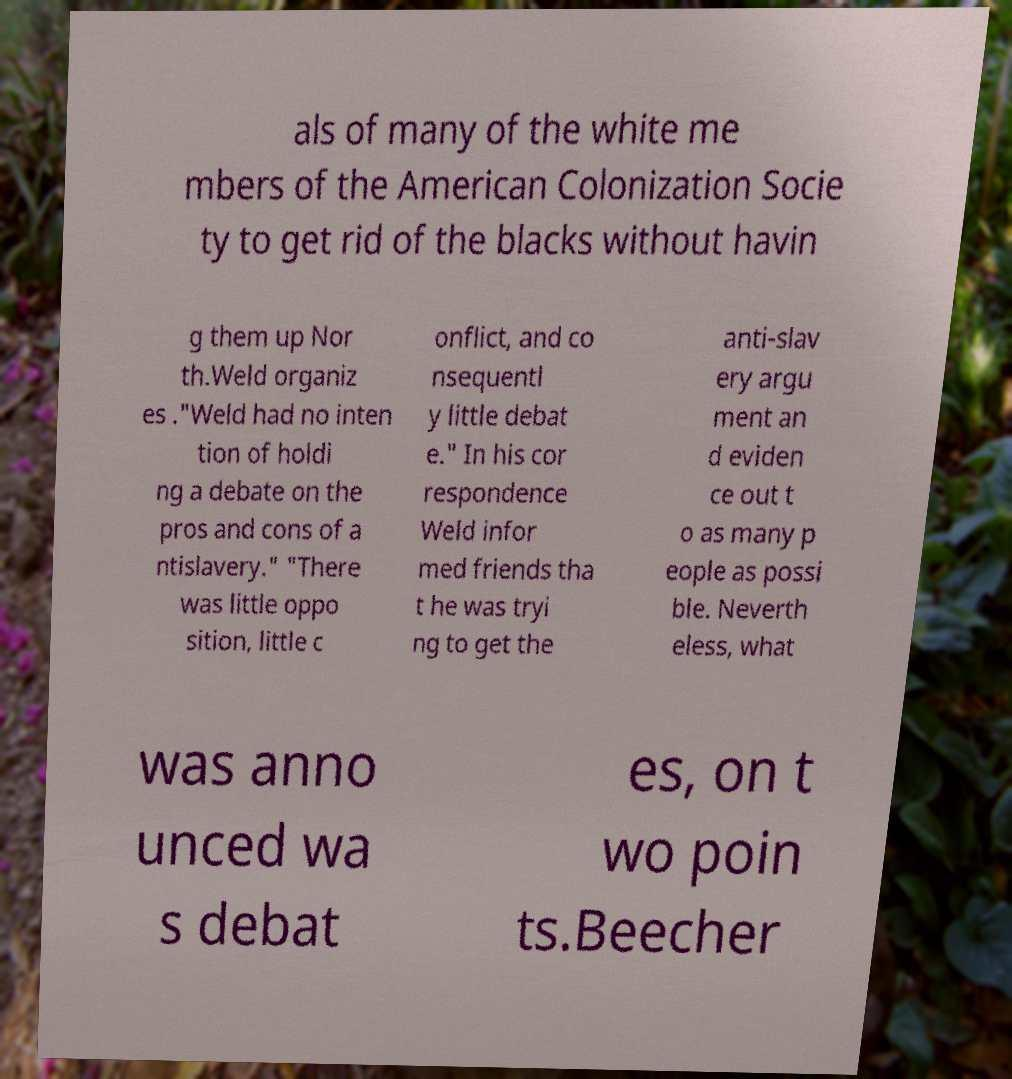Can you read and provide the text displayed in the image?This photo seems to have some interesting text. Can you extract and type it out for me? als of many of the white me mbers of the American Colonization Socie ty to get rid of the blacks without havin g them up Nor th.Weld organiz es ."Weld had no inten tion of holdi ng a debate on the pros and cons of a ntislavery." "There was little oppo sition, little c onflict, and co nsequentl y little debat e." In his cor respondence Weld infor med friends tha t he was tryi ng to get the anti-slav ery argu ment an d eviden ce out t o as many p eople as possi ble. Neverth eless, what was anno unced wa s debat es, on t wo poin ts.Beecher 